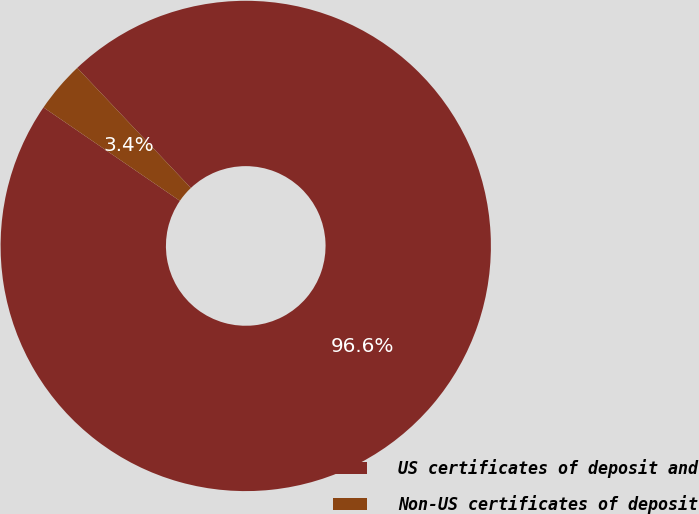Convert chart to OTSL. <chart><loc_0><loc_0><loc_500><loc_500><pie_chart><fcel>US certificates of deposit and<fcel>Non-US certificates of deposit<nl><fcel>96.62%<fcel>3.38%<nl></chart> 